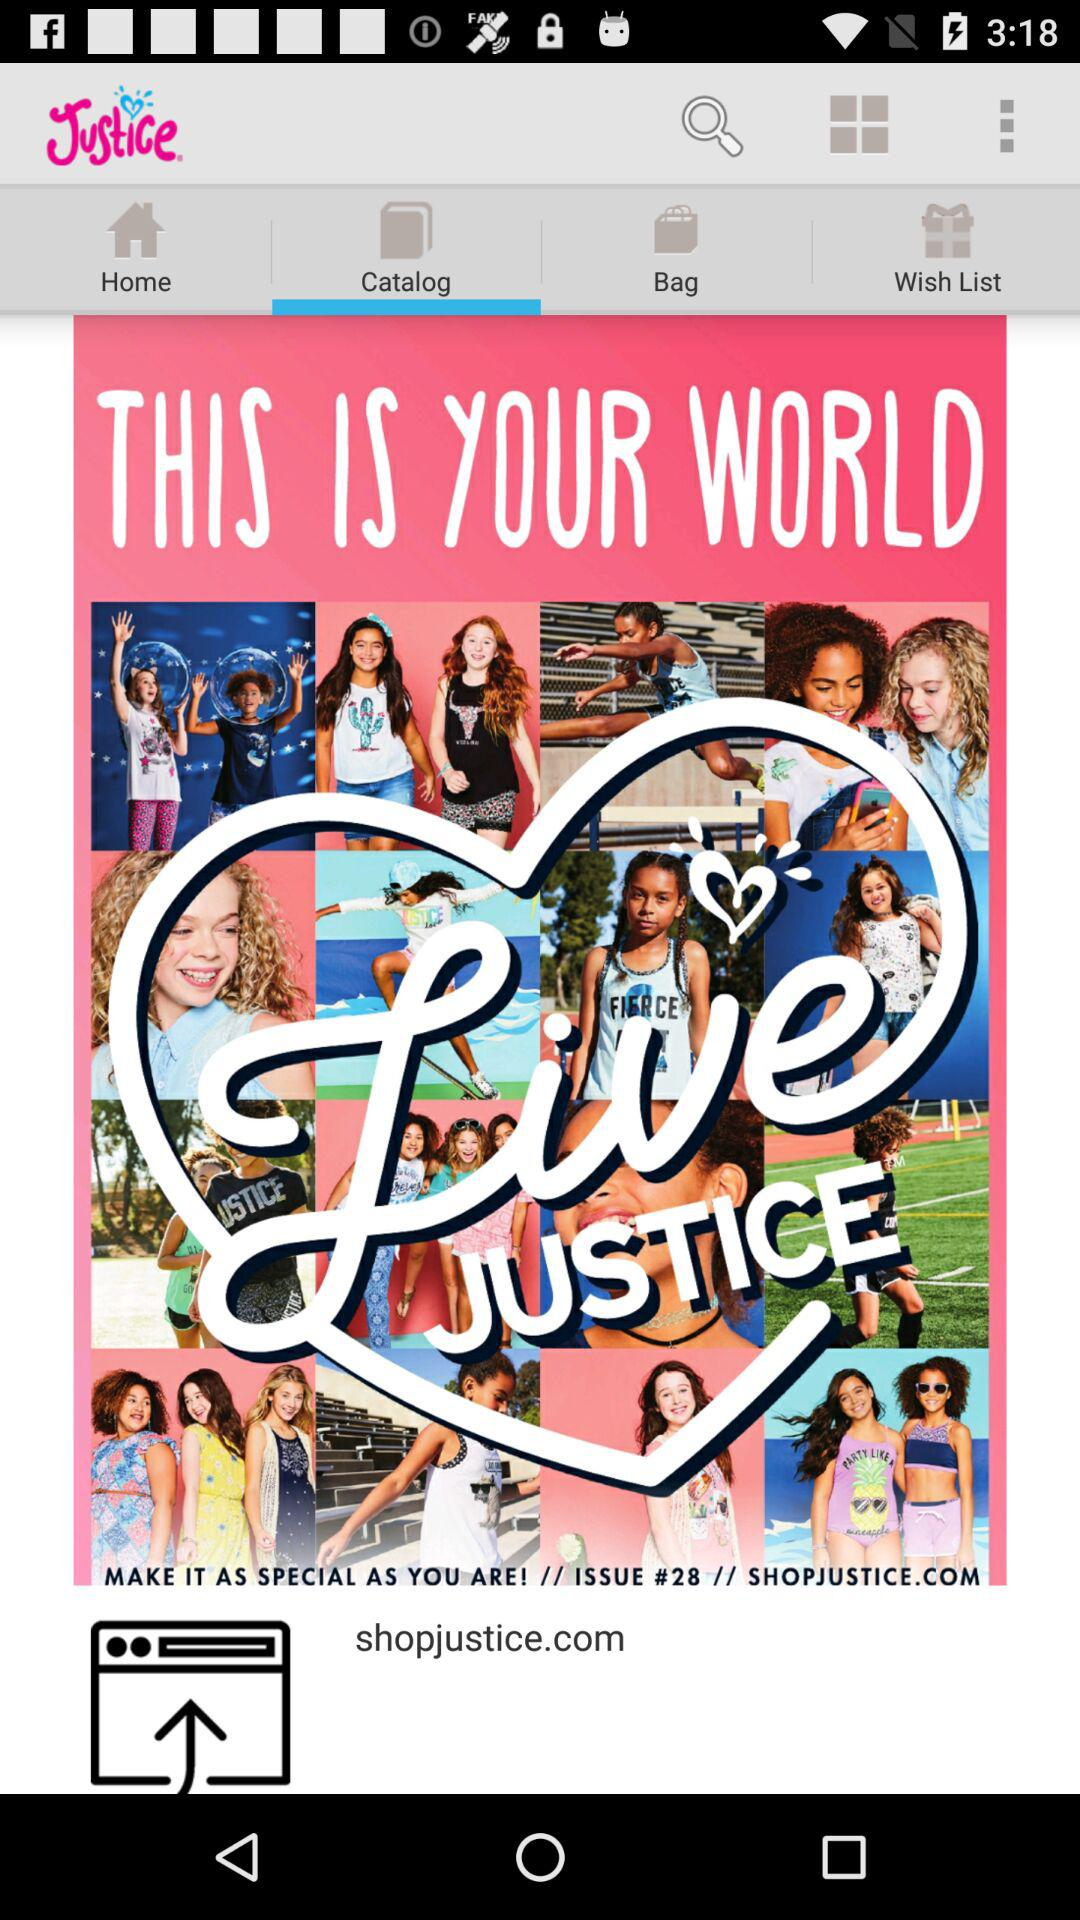What is the name of the application? The name of the application is "Justice". 